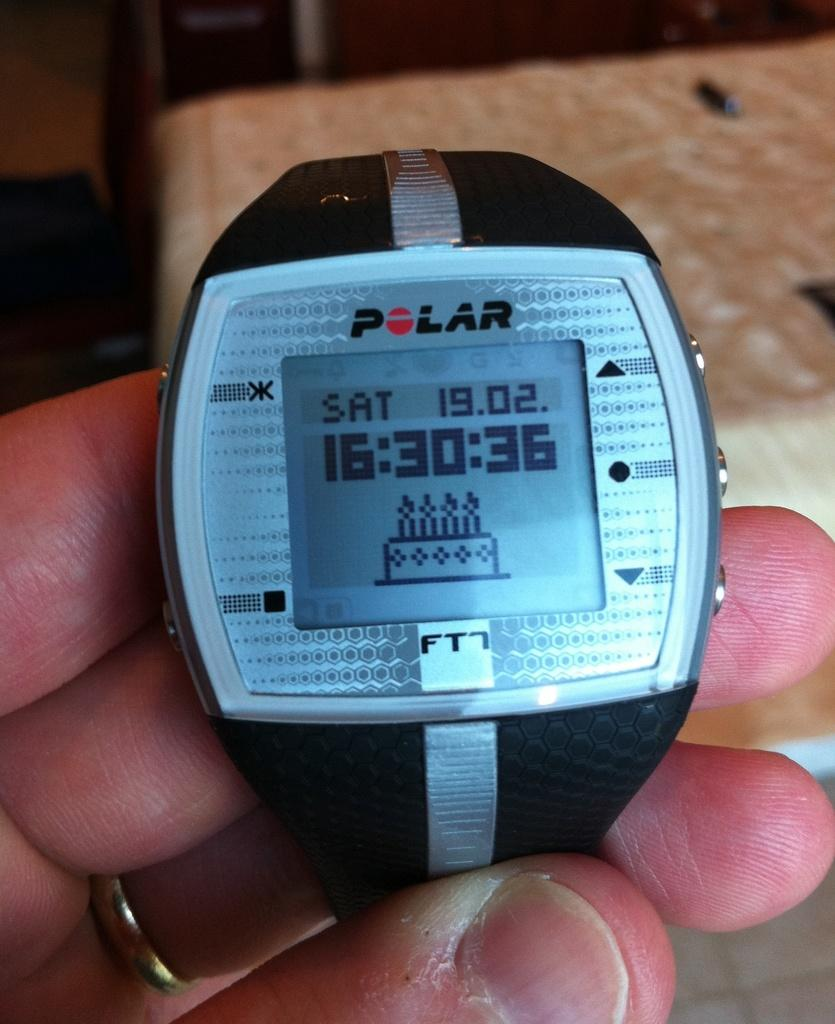<image>
Write a terse but informative summary of the picture. a polar watch that shows a birthday cake for sat 1902 